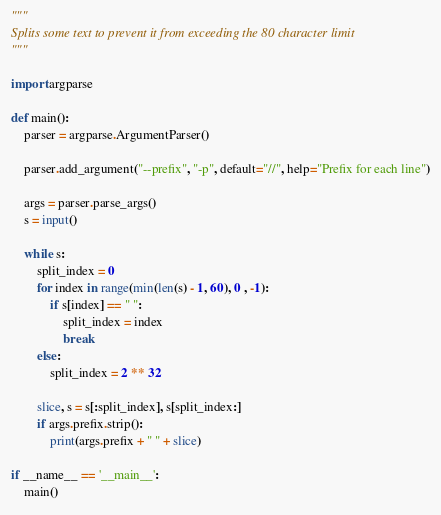<code> <loc_0><loc_0><loc_500><loc_500><_Python_>"""
Splits some text to prevent it from exceeding the 80 character limit
"""

import argparse

def main():
	parser = argparse.ArgumentParser()
	
	parser.add_argument("--prefix", "-p", default="//", help="Prefix for each line")
	
	args = parser.parse_args()
	s = input()

	while s:
		split_index = 0
		for index in range(min(len(s) - 1, 60), 0 , -1):
			if s[index] == " ":
				split_index = index
				break
		else:
			split_index = 2 ** 32
			
		slice, s = s[:split_index], s[split_index:]
		if args.prefix.strip():
			print(args.prefix + " " + slice)
		
if __name__ == '__main__':
	main()</code> 